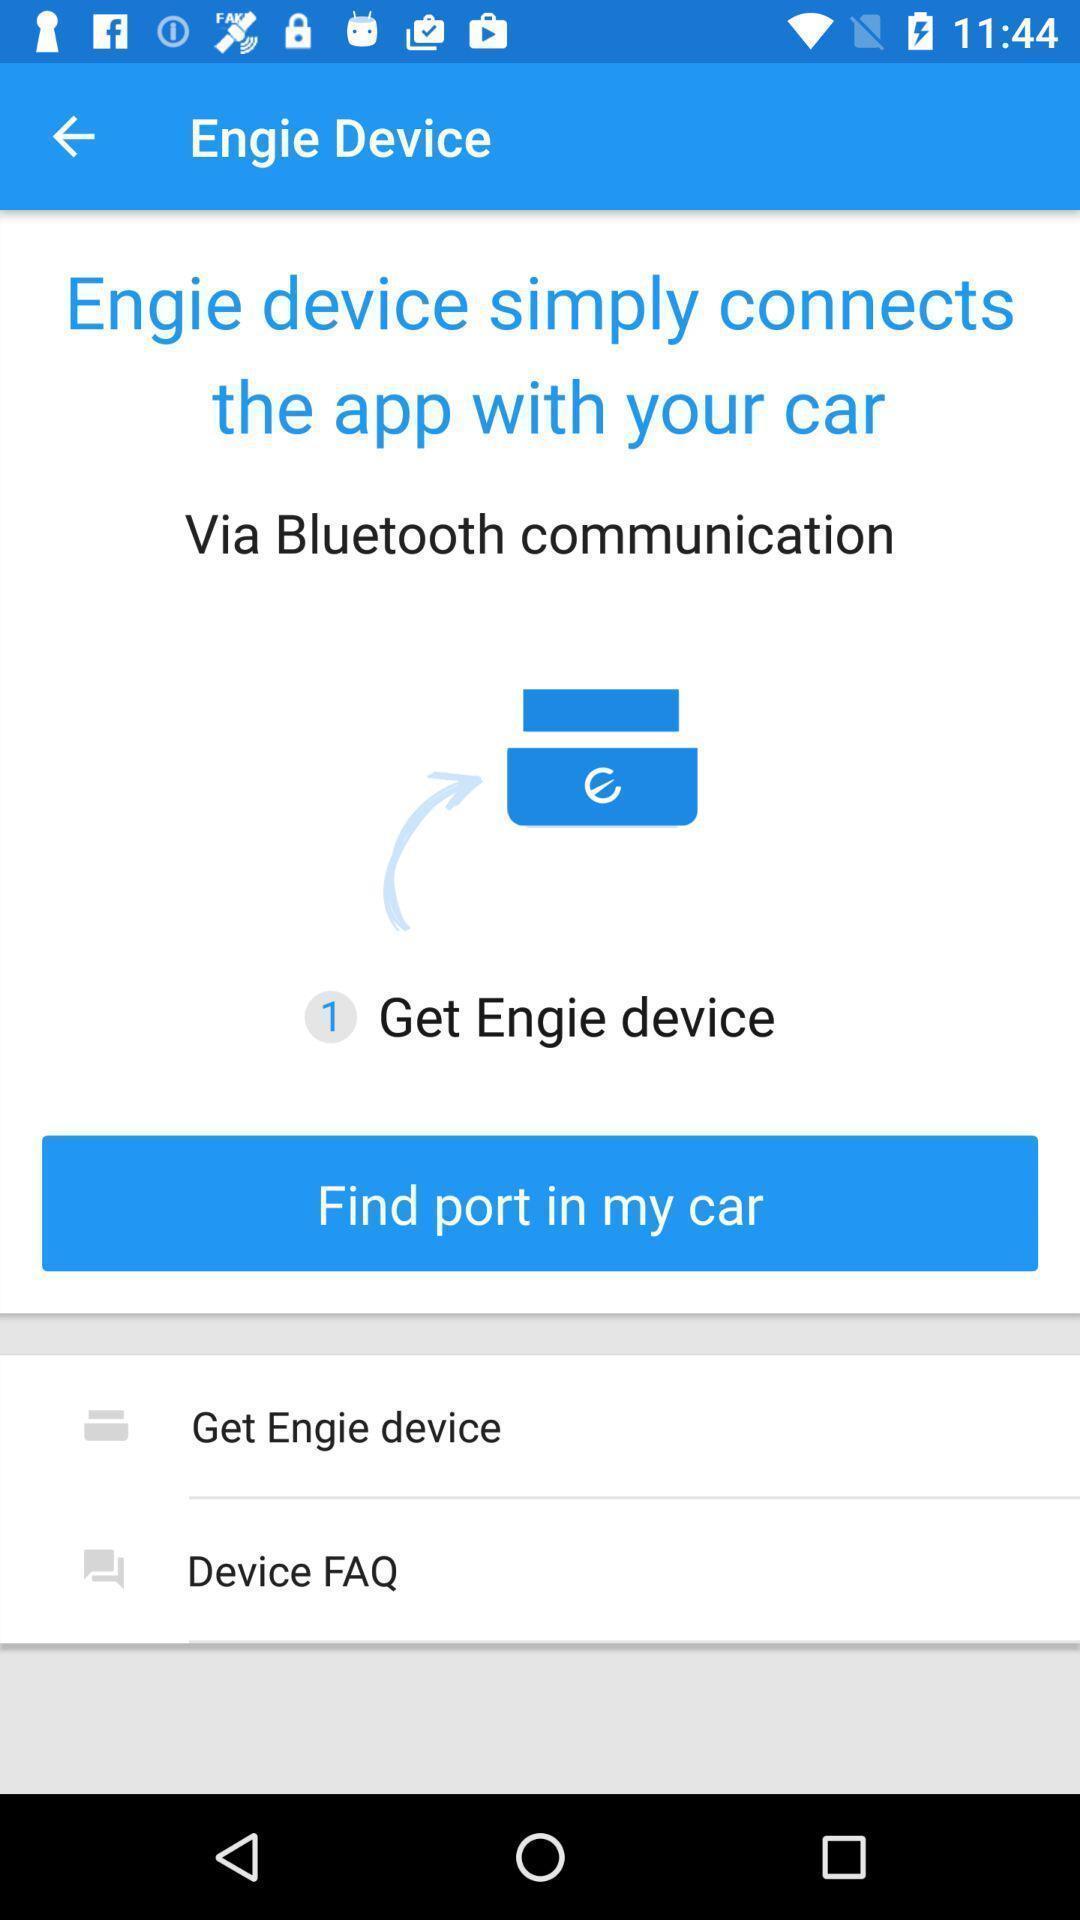Give me a summary of this screen capture. Screen showing find port in my car option. 